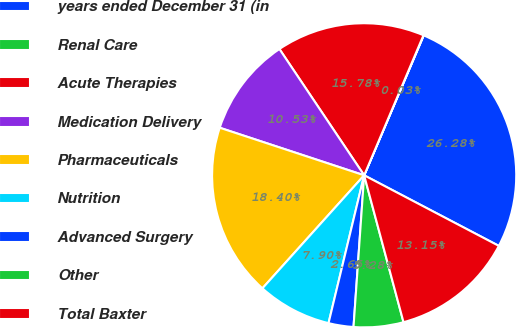Convert chart to OTSL. <chart><loc_0><loc_0><loc_500><loc_500><pie_chart><fcel>years ended December 31 (in<fcel>Renal Care<fcel>Acute Therapies<fcel>Medication Delivery<fcel>Pharmaceuticals<fcel>Nutrition<fcel>Advanced Surgery<fcel>Other<fcel>Total Baxter<nl><fcel>26.28%<fcel>0.03%<fcel>15.78%<fcel>10.53%<fcel>18.4%<fcel>7.9%<fcel>2.65%<fcel>5.28%<fcel>13.15%<nl></chart> 